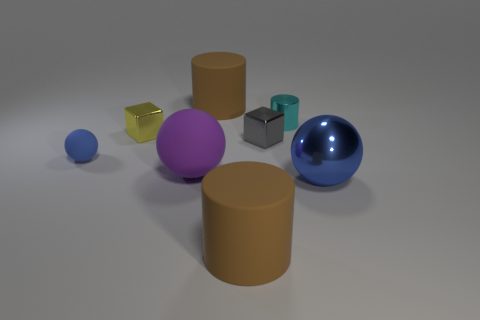Is the color of the tiny sphere the same as the big metal sphere?
Give a very brief answer. Yes. Is the number of brown cylinders that are behind the purple rubber ball less than the number of things on the right side of the yellow metal thing?
Make the answer very short. Yes. What size is the sphere to the right of the brown matte object that is behind the large brown cylinder in front of the small gray cube?
Your response must be concise. Large. There is a rubber thing that is in front of the small cyan metallic object and behind the purple matte sphere; how big is it?
Keep it short and to the point. Small. There is a large shiny thing in front of the yellow object on the left side of the large blue object; what is its shape?
Offer a terse response. Sphere. Is there any other thing that is the same color as the big rubber ball?
Your response must be concise. No. What is the shape of the big matte thing behind the small blue matte thing?
Offer a very short reply. Cylinder. The small metal thing that is both left of the cyan thing and behind the gray block has what shape?
Provide a succinct answer. Cube. What number of cyan things are either tiny balls or small cylinders?
Ensure brevity in your answer.  1. There is a big object on the right side of the tiny shiny cylinder; does it have the same color as the small sphere?
Ensure brevity in your answer.  Yes. 